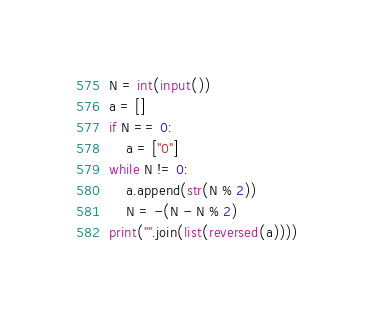<code> <loc_0><loc_0><loc_500><loc_500><_Python_>N = int(input())
a = []
if N == 0:
    a = ["0"]
while N != 0:
    a.append(str(N % 2))
    N = -(N - N % 2) 
print("".join(list(reversed(a))))</code> 